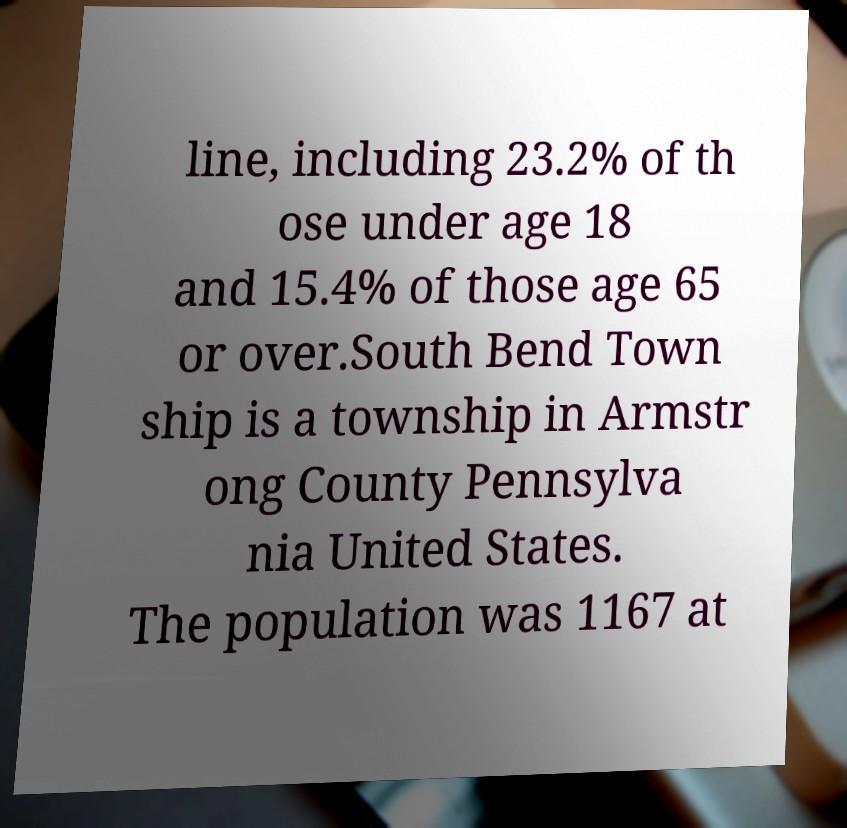What messages or text are displayed in this image? I need them in a readable, typed format. line, including 23.2% of th ose under age 18 and 15.4% of those age 65 or over.South Bend Town ship is a township in Armstr ong County Pennsylva nia United States. The population was 1167 at 